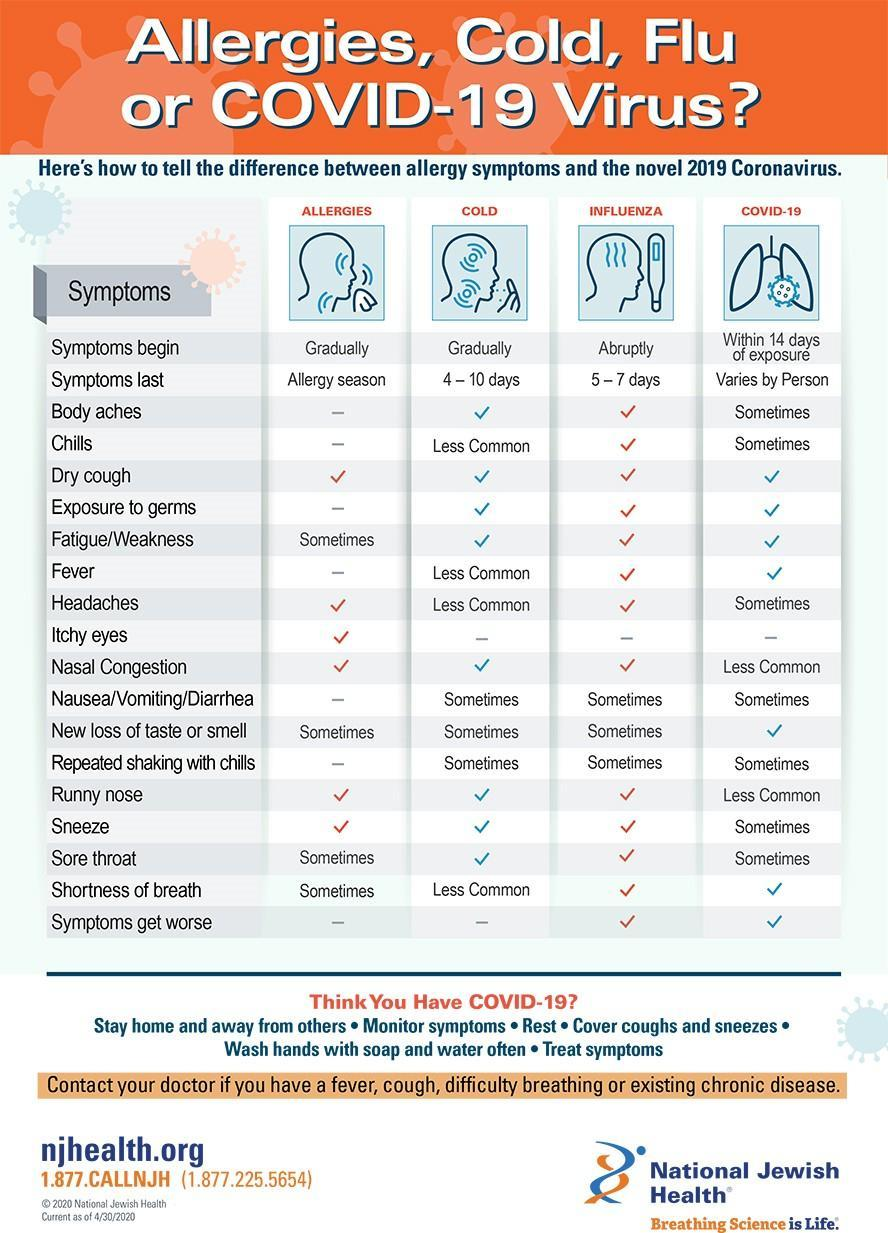For which two illnesses do the symptoms begin gradually?
Answer the question with a short phrase. ALLERGIES, COLD 